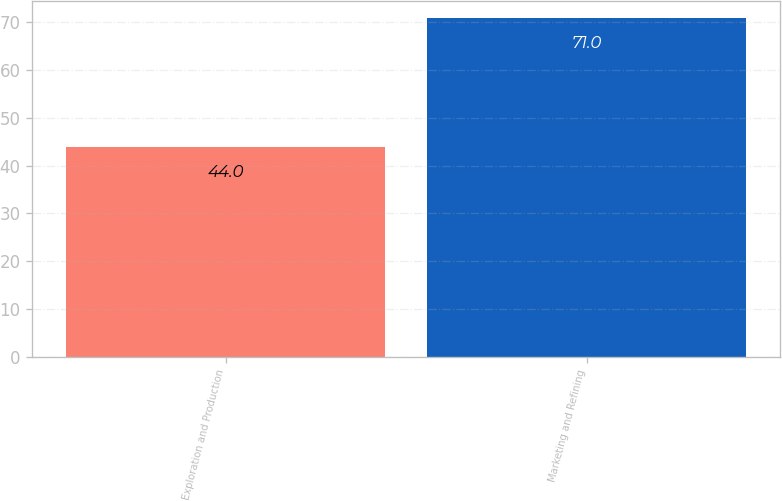Convert chart to OTSL. <chart><loc_0><loc_0><loc_500><loc_500><bar_chart><fcel>Exploration and Production<fcel>Marketing and Refining<nl><fcel>44<fcel>71<nl></chart> 